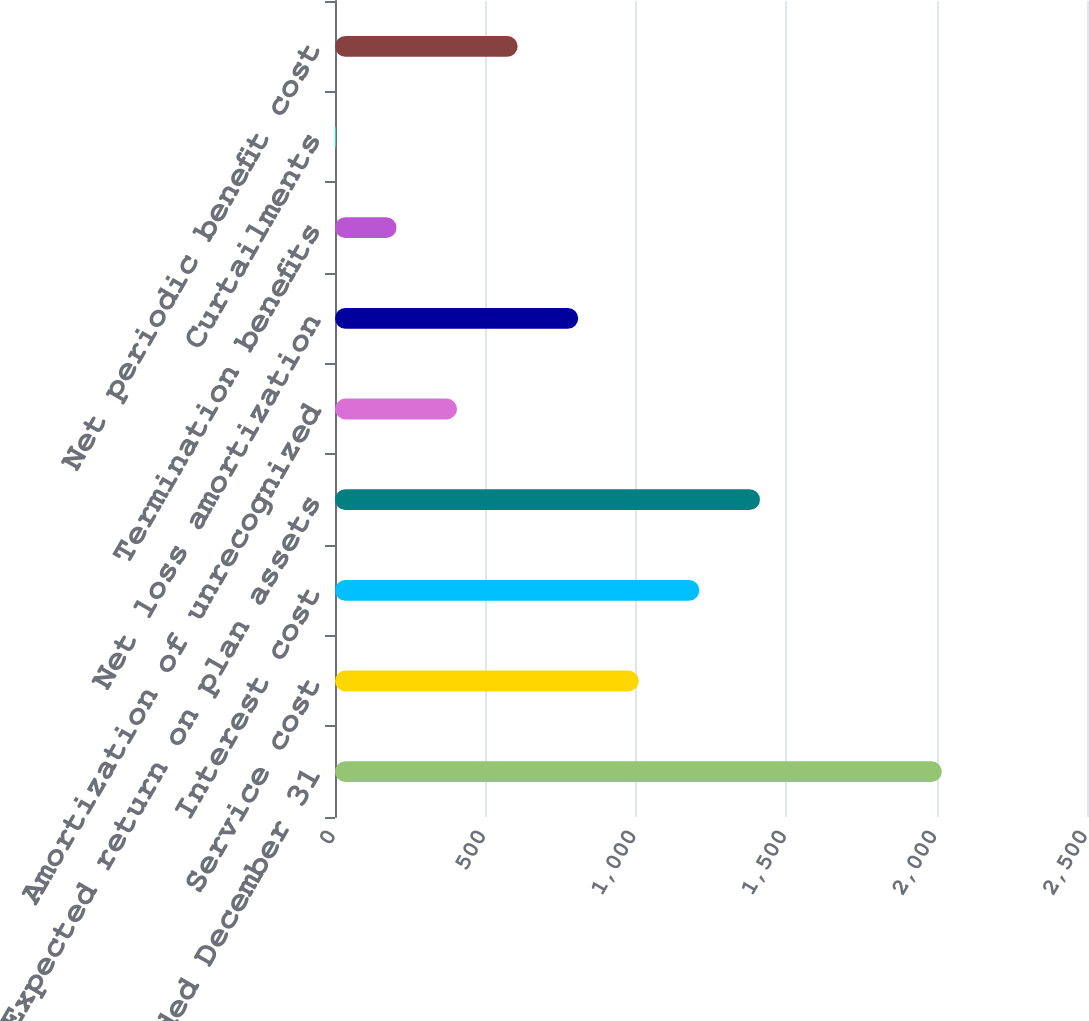<chart> <loc_0><loc_0><loc_500><loc_500><bar_chart><fcel>Years Ended December 31<fcel>Service cost<fcel>Interest cost<fcel>Expected return on plan assets<fcel>Amortization of unrecognized<fcel>Net loss amortization<fcel>Termination benefits<fcel>Curtailments<fcel>Net periodic benefit cost<nl><fcel>2017<fcel>1010<fcel>1211.4<fcel>1412.8<fcel>405.8<fcel>808.6<fcel>204.4<fcel>3<fcel>607.2<nl></chart> 